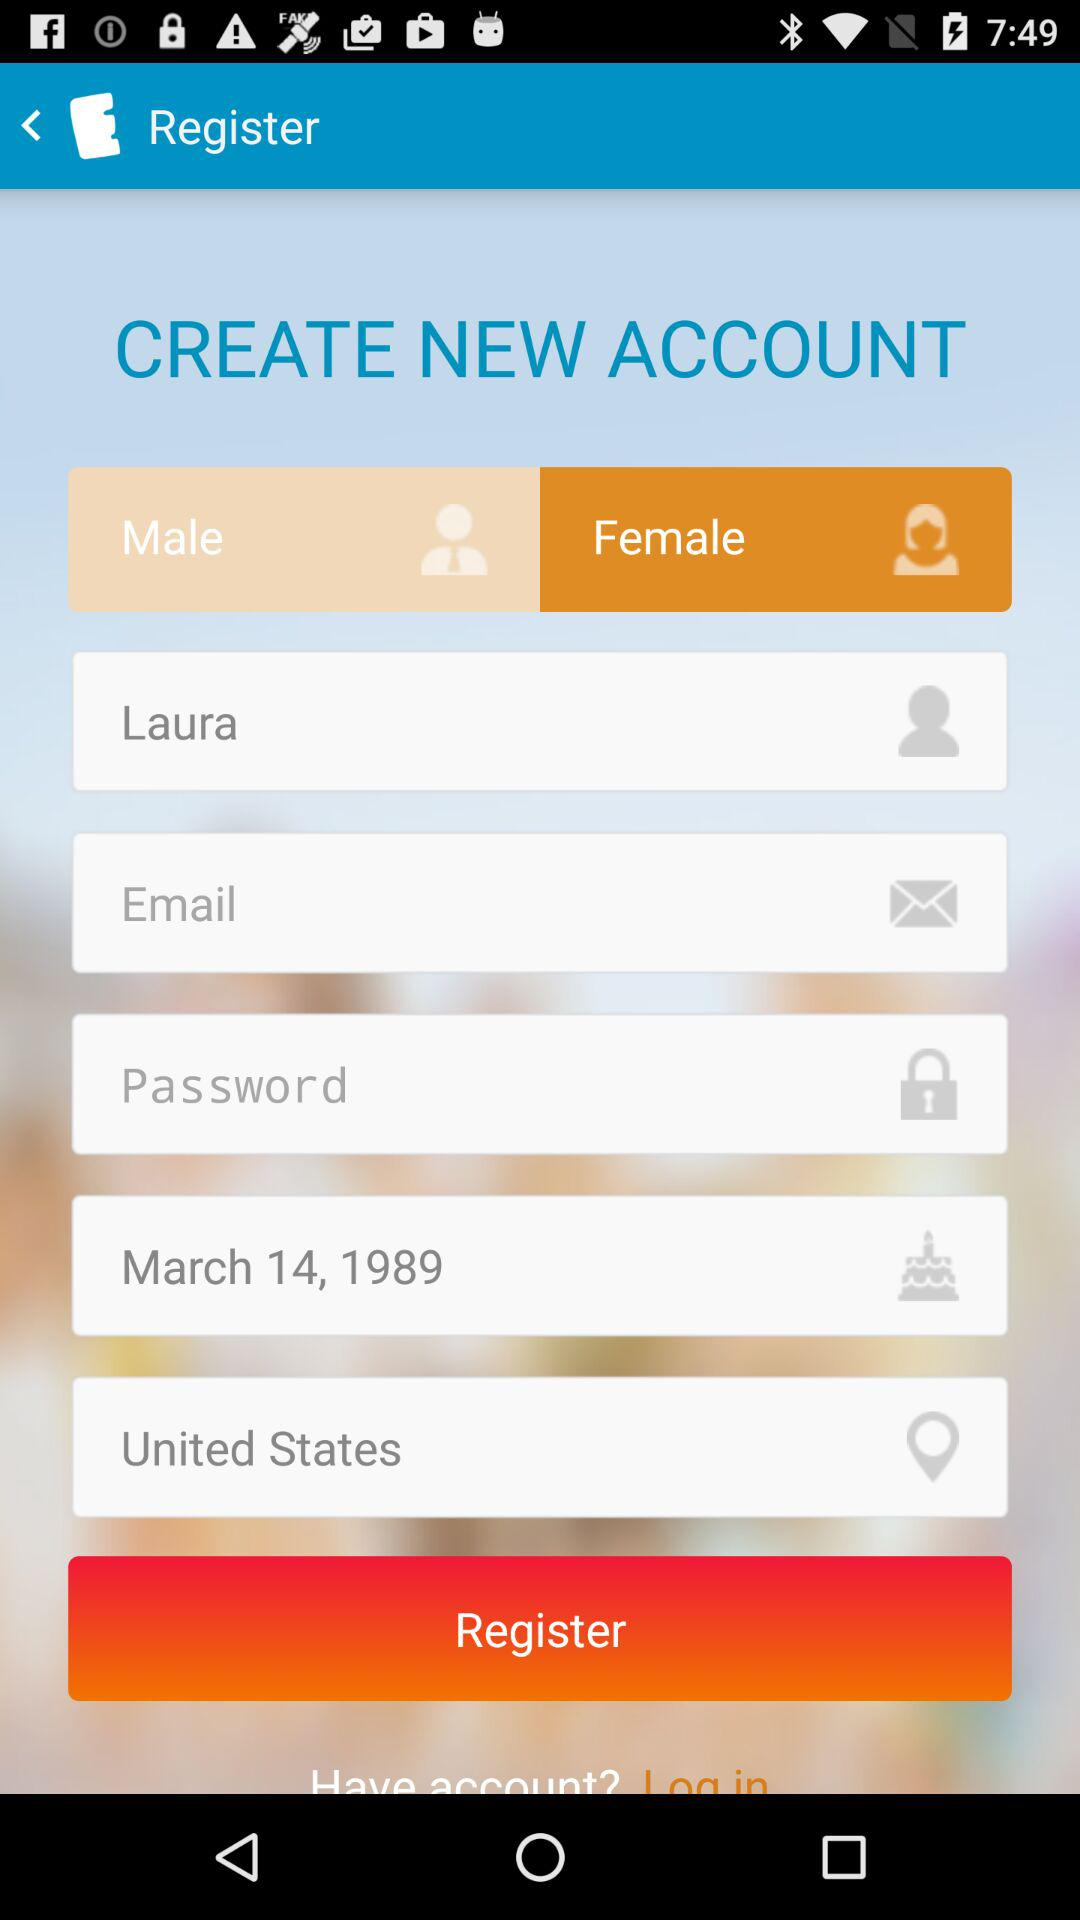Which gender is chosen? The chosen gender is female. 